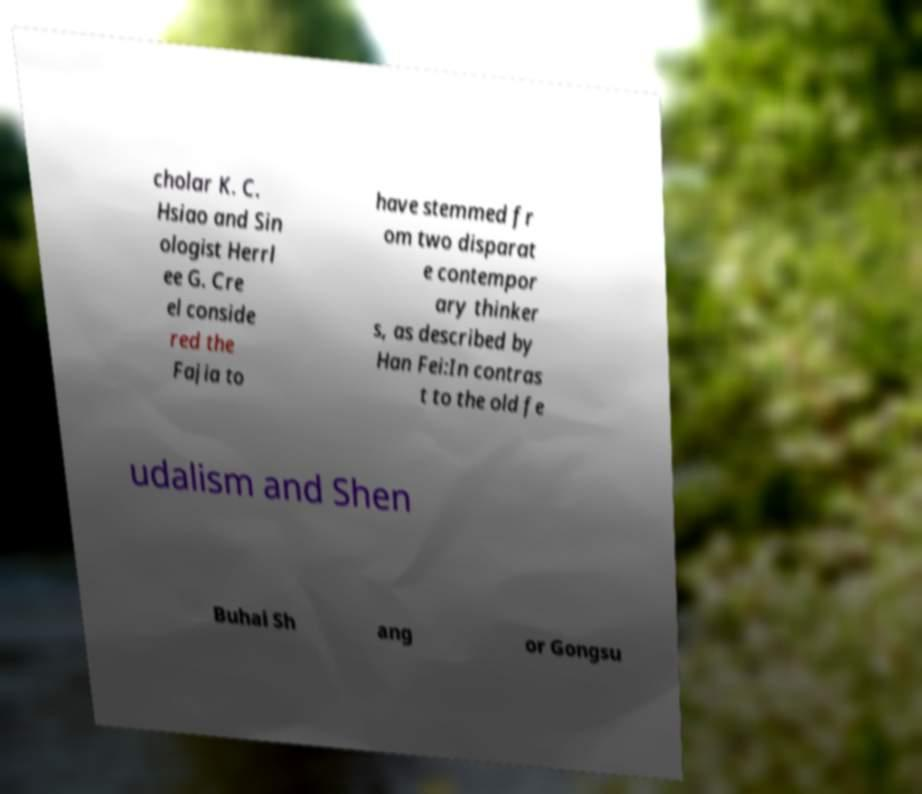Could you assist in decoding the text presented in this image and type it out clearly? cholar K. C. Hsiao and Sin ologist Herrl ee G. Cre el conside red the Fajia to have stemmed fr om two disparat e contempor ary thinker s, as described by Han Fei:In contras t to the old fe udalism and Shen Buhai Sh ang or Gongsu 